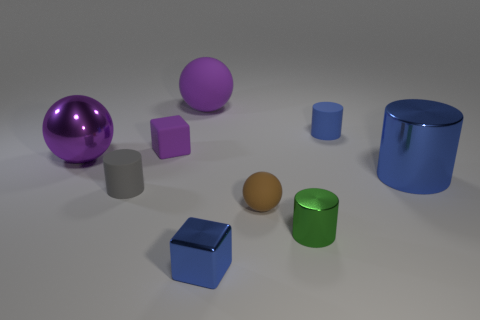What is the tiny object that is on the right side of the brown object and in front of the tiny gray thing made of?
Offer a terse response. Metal. There is a large cylinder; is its color the same as the matte cylinder that is behind the big cylinder?
Offer a very short reply. Yes. There is a green object that is the same size as the purple matte block; what is it made of?
Keep it short and to the point. Metal. Are there any large purple cubes that have the same material as the big blue object?
Provide a succinct answer. No. What number of purple metal things are there?
Offer a very short reply. 1. Is the material of the tiny blue block the same as the purple sphere that is to the right of the small purple rubber block?
Make the answer very short. No. There is a big thing that is the same color as the small shiny cube; what is it made of?
Make the answer very short. Metal. What number of small shiny cylinders have the same color as the large matte sphere?
Provide a short and direct response. 0. The brown matte thing has what size?
Ensure brevity in your answer.  Small. Do the gray thing and the large shiny thing left of the tiny gray thing have the same shape?
Offer a terse response. No. 